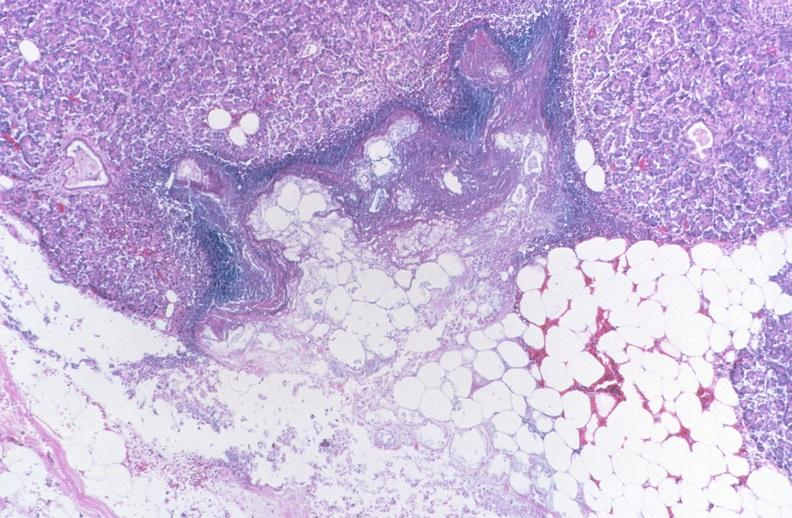what does this image show?
Answer the question using a single word or phrase. Pancreatic fat necrosis 